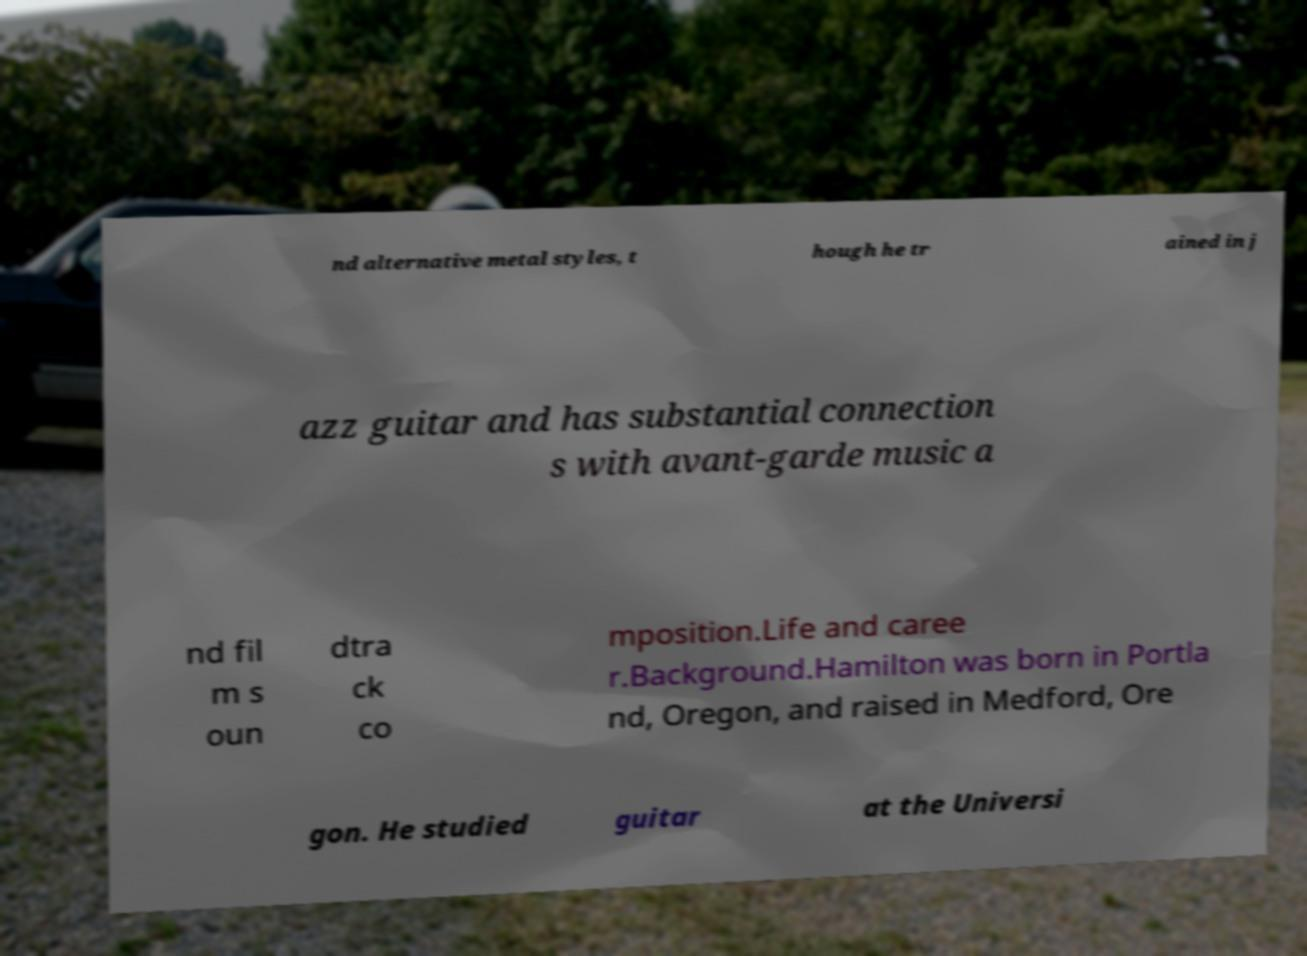Please read and relay the text visible in this image. What does it say? nd alternative metal styles, t hough he tr ained in j azz guitar and has substantial connection s with avant-garde music a nd fil m s oun dtra ck co mposition.Life and caree r.Background.Hamilton was born in Portla nd, Oregon, and raised in Medford, Ore gon. He studied guitar at the Universi 